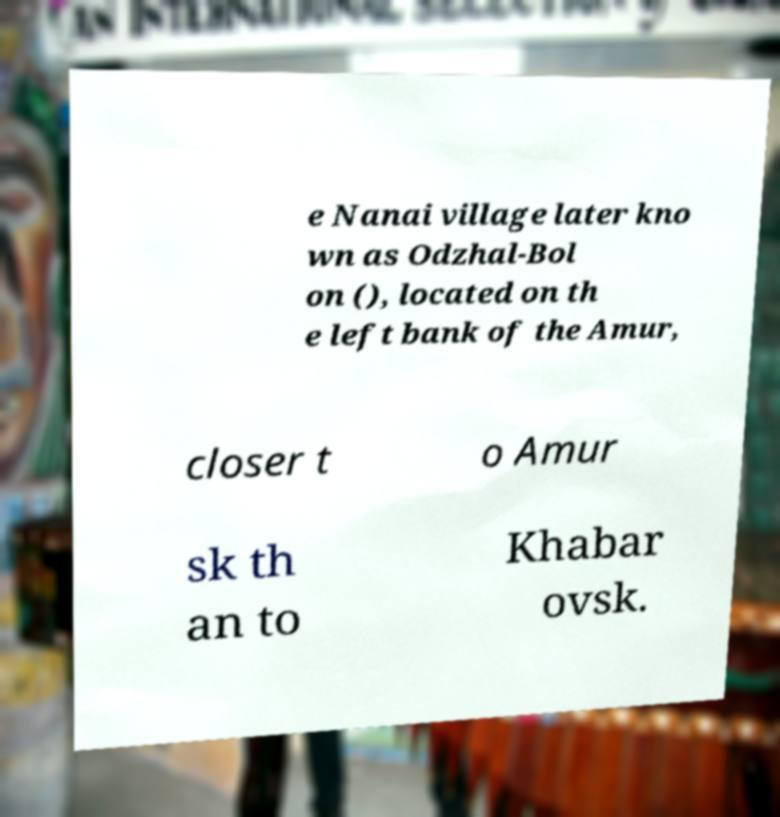For documentation purposes, I need the text within this image transcribed. Could you provide that? e Nanai village later kno wn as Odzhal-Bol on (), located on th e left bank of the Amur, closer t o Amur sk th an to Khabar ovsk. 